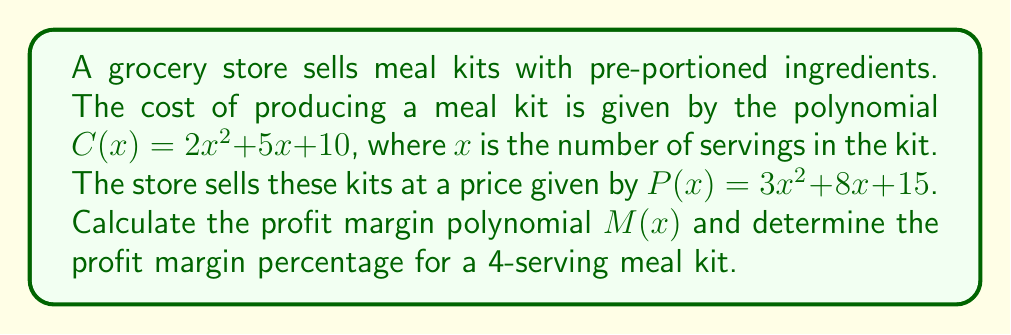What is the answer to this math problem? To solve this problem, we'll follow these steps:

1) First, let's define the profit margin polynomial $M(x)$:
   $M(x) = P(x) - C(x)$

2) Substitute the given polynomials:
   $M(x) = (3x^2 + 8x + 15) - (2x^2 + 5x + 10)$

3) Simplify by combining like terms:
   $M(x) = (3x^2 - 2x^2) + (8x - 5x) + (15 - 10)$
   $M(x) = x^2 + 3x + 5$

4) To calculate the profit margin percentage for a 4-serving meal kit:
   a) Calculate the profit for x = 4:
      $M(4) = 4^2 + 3(4) + 5 = 16 + 12 + 5 = 33$

   b) Calculate the selling price for x = 4:
      $P(4) = 3(4^2) + 8(4) + 15 = 48 + 32 + 15 = 95$

   c) Calculate the profit margin percentage:
      Profit Margin % = $\frac{\text{Profit}}{\text{Selling Price}} \times 100\%$
      $= \frac{33}{95} \times 100\% \approx 34.74\%$
Answer: The profit margin polynomial is $M(x) = x^2 + 3x + 5$, and the profit margin percentage for a 4-serving meal kit is approximately 34.74%. 